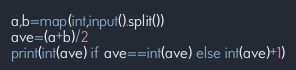Convert code to text. <code><loc_0><loc_0><loc_500><loc_500><_Python_>a,b=map(int,input().split())
ave=(a+b)/2
print(int(ave) if ave==int(ave) else int(ave)+1)</code> 